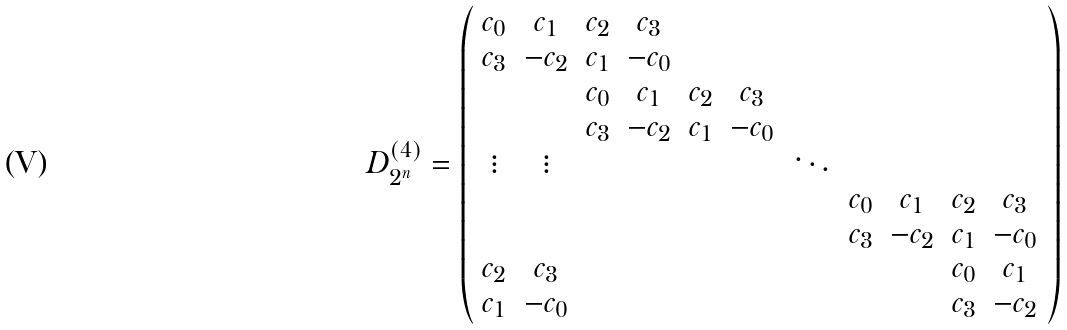Convert formula to latex. <formula><loc_0><loc_0><loc_500><loc_500>D ^ { ( 4 ) } _ { 2 ^ { n } } = \left ( \begin{array} { c c c c c c c c c c c } c _ { 0 } & c _ { 1 } & c _ { 2 } & c _ { 3 } \\ c _ { 3 } & - c _ { 2 } & c _ { 1 } & - c _ { 0 } \\ & & c _ { 0 } & c _ { 1 } & c _ { 2 } & c _ { 3 } \\ & & c _ { 3 } & - c _ { 2 } & c _ { 1 } & - c _ { 0 } \\ \vdots & \vdots & & & & & \ddots \\ & & & & & & & c _ { 0 } & c _ { 1 } & c _ { 2 } & c _ { 3 } \\ & & & & & & & c _ { 3 } & - c _ { 2 } & c _ { 1 } & - c _ { 0 } \\ c _ { 2 } & c _ { 3 } & & & & & & & & c _ { 0 } & c _ { 1 } \\ c _ { 1 } & - c _ { 0 } & & & & & & & & c _ { 3 } & - c _ { 2 } \end{array} \right )</formula> 